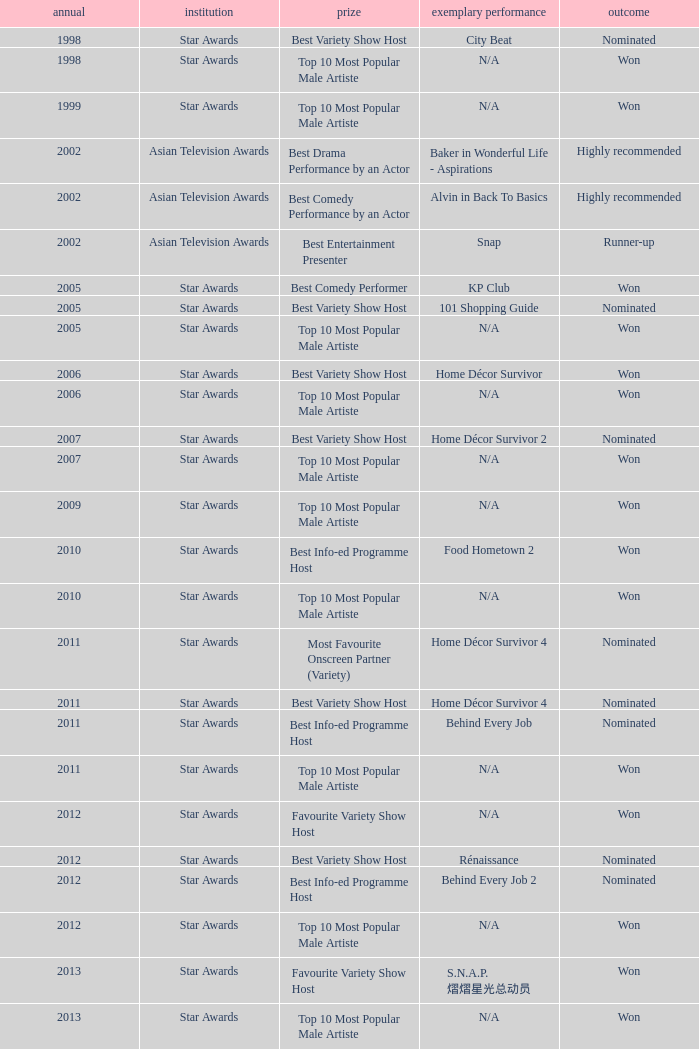What is the award for 1998 with Representative Work of city beat? Best Variety Show Host. 